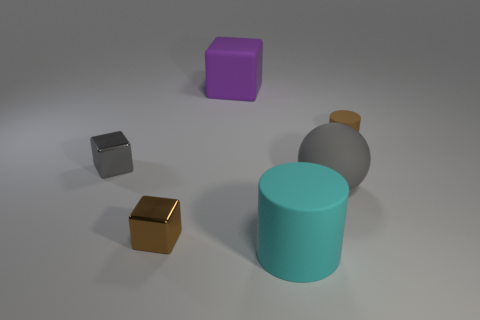Which of these objects is tallest? The tallest object in the image appears to be the cyan-colored cylinder. 